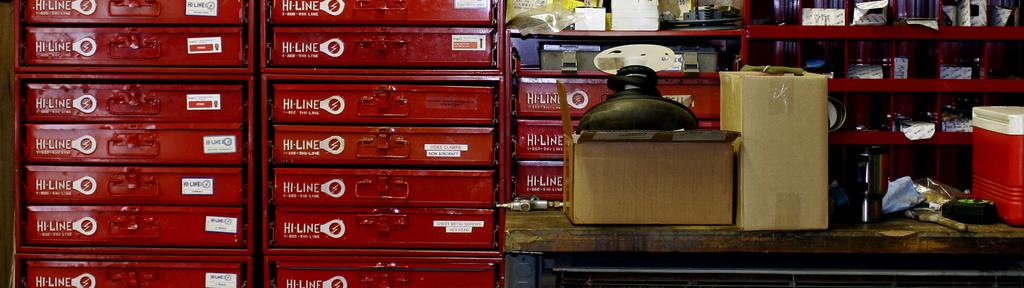What brand are the red draws?
Provide a short and direct response. Hi-line. 